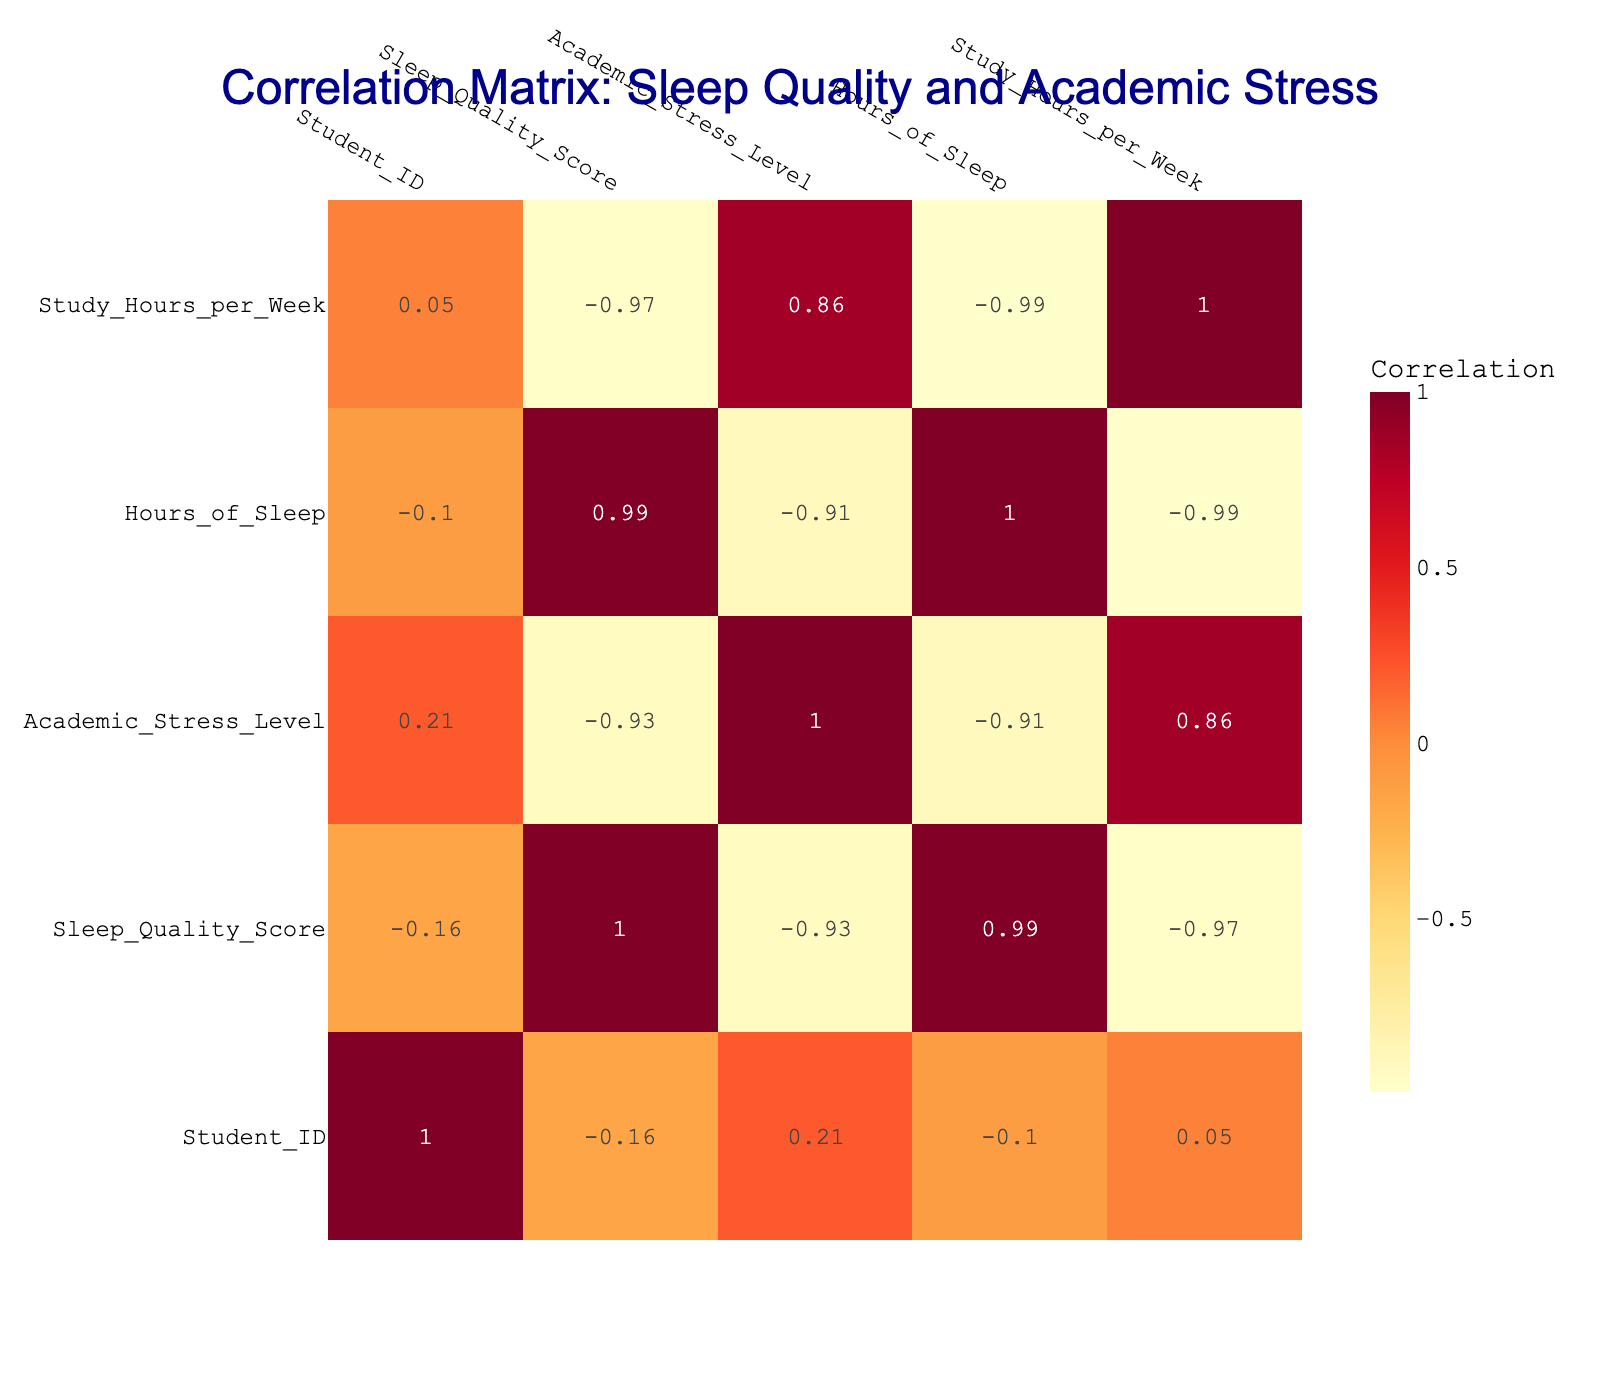What is the correlation between Sleep Quality Score and Academic Stress Level? The correlation value between Sleep Quality Score and Academic Stress Level is -0.77, which indicates a strong negative correlation. This means that as sleep quality decreases, academic stress levels tend to increase.
Answer: -0.77 Is there a positive correlation between Hours of Sleep and Sleep Quality Score? The correlation value between Hours of Sleep and Sleep Quality Score is 0.81, indicating a strong positive correlation. This implies that more hours of sleep are associated with better sleep quality.
Answer: Yes What is the average Academic Stress Level for students with Sleep Quality Scores of 7 or higher? The Sleep Quality Scores of 7 or higher correspond to students with IDs 1, 3, 4, 6, and 8. Their Academic Stress Levels are 3, 2, 6, 4, and 1 respectively. Summing these gives 16 and dividing by 5 (the number of students) results in an average of 3.2.
Answer: 3.2 Do students who study more hours per week generally experience higher Academic Stress Levels? Analyzing the correlation between Study Hours per Week and Academic Stress Level reveals a correlation of -0.04, indicating no significant relationship. Therefore, the assumption that more study hours lead to higher stress is not supported.
Answer: No What is the difference in average Sleep Quality Score between students with Academic Stress Levels of 1 to 4 and those with 5 to 9? For levels 1 to 4 (ID 1, 3, 4, 6, 8), the Sleep Quality Scores are 8, 9, 6, 7, and 10, with an average of (8 + 9 + 6 + 7 + 10) / 5 = 8. The levels 5 to 9 (ID 2, 5, 7, 9, 10) have scores 5, 4, 3, 5, and 6, with an average of (5 + 4 + 3 + 5 + 6) / 5 = 4.6. The difference is 8 - 4.6 = 3.4.
Answer: 3.4 What percentage of students reported a Sleep Quality Score below 5? Students with a Sleep Quality Score below 5 are those with IDs 2, 5, and 7, which accounts for 3 out of 10 students in total. Therefore, (3/10) * 100% = 30%.
Answer: 30% 